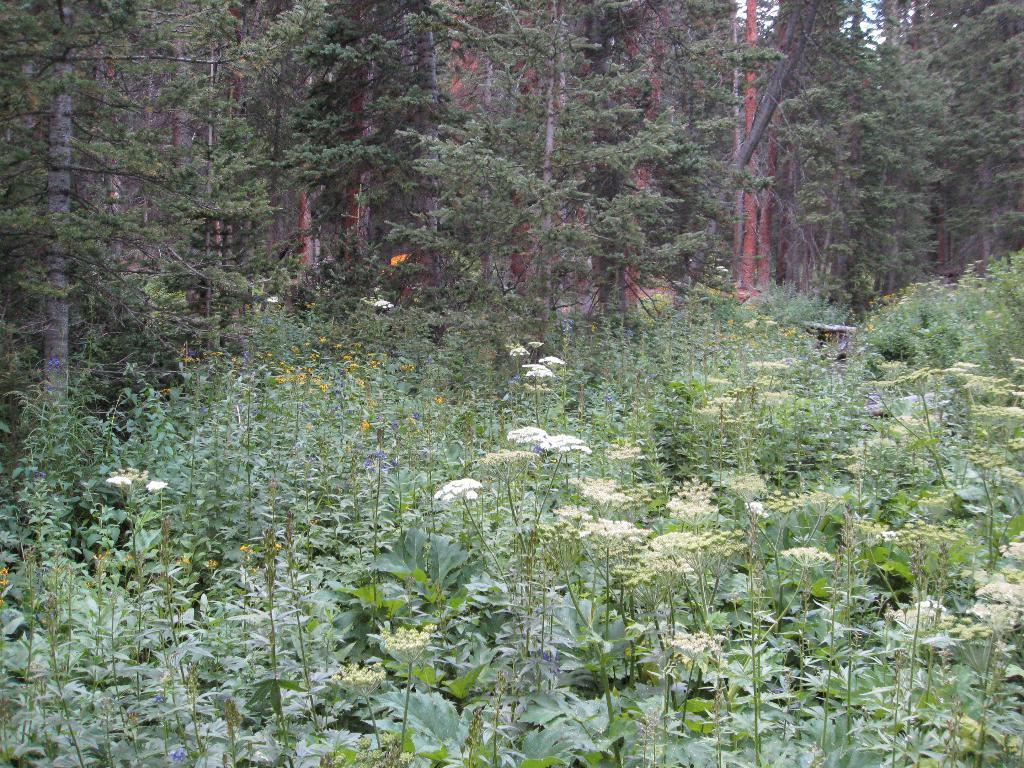How would you summarize this image in a sentence or two? In this picture we can see many trees. At the bottom we can see flowers on the plant. In the top right there is a sky. In the bottom left we can see the leaves. In the background there is a mountain. 